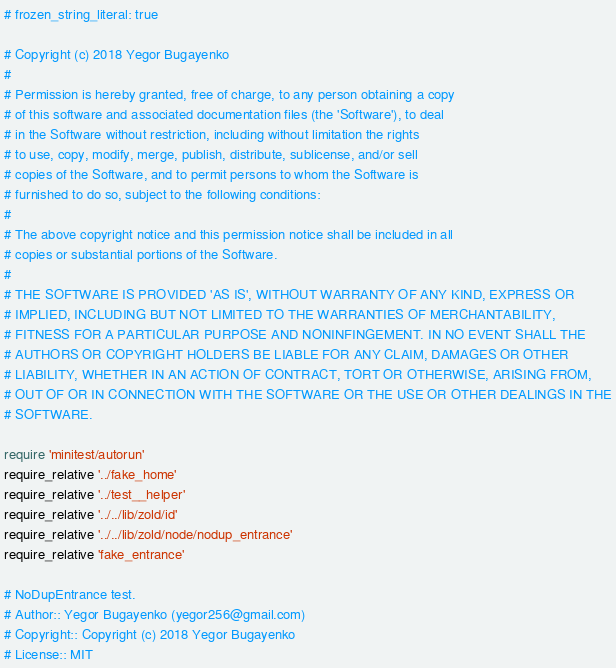<code> <loc_0><loc_0><loc_500><loc_500><_Ruby_># frozen_string_literal: true

# Copyright (c) 2018 Yegor Bugayenko
#
# Permission is hereby granted, free of charge, to any person obtaining a copy
# of this software and associated documentation files (the 'Software'), to deal
# in the Software without restriction, including without limitation the rights
# to use, copy, modify, merge, publish, distribute, sublicense, and/or sell
# copies of the Software, and to permit persons to whom the Software is
# furnished to do so, subject to the following conditions:
#
# The above copyright notice and this permission notice shall be included in all
# copies or substantial portions of the Software.
#
# THE SOFTWARE IS PROVIDED 'AS IS', WITHOUT WARRANTY OF ANY KIND, EXPRESS OR
# IMPLIED, INCLUDING BUT NOT LIMITED TO THE WARRANTIES OF MERCHANTABILITY,
# FITNESS FOR A PARTICULAR PURPOSE AND NONINFINGEMENT. IN NO EVENT SHALL THE
# AUTHORS OR COPYRIGHT HOLDERS BE LIABLE FOR ANY CLAIM, DAMAGES OR OTHER
# LIABILITY, WHETHER IN AN ACTION OF CONTRACT, TORT OR OTHERWISE, ARISING FROM,
# OUT OF OR IN CONNECTION WITH THE SOFTWARE OR THE USE OR OTHER DEALINGS IN THE
# SOFTWARE.

require 'minitest/autorun'
require_relative '../fake_home'
require_relative '../test__helper'
require_relative '../../lib/zold/id'
require_relative '../../lib/zold/node/nodup_entrance'
require_relative 'fake_entrance'

# NoDupEntrance test.
# Author:: Yegor Bugayenko (yegor256@gmail.com)
# Copyright:: Copyright (c) 2018 Yegor Bugayenko
# License:: MIT</code> 